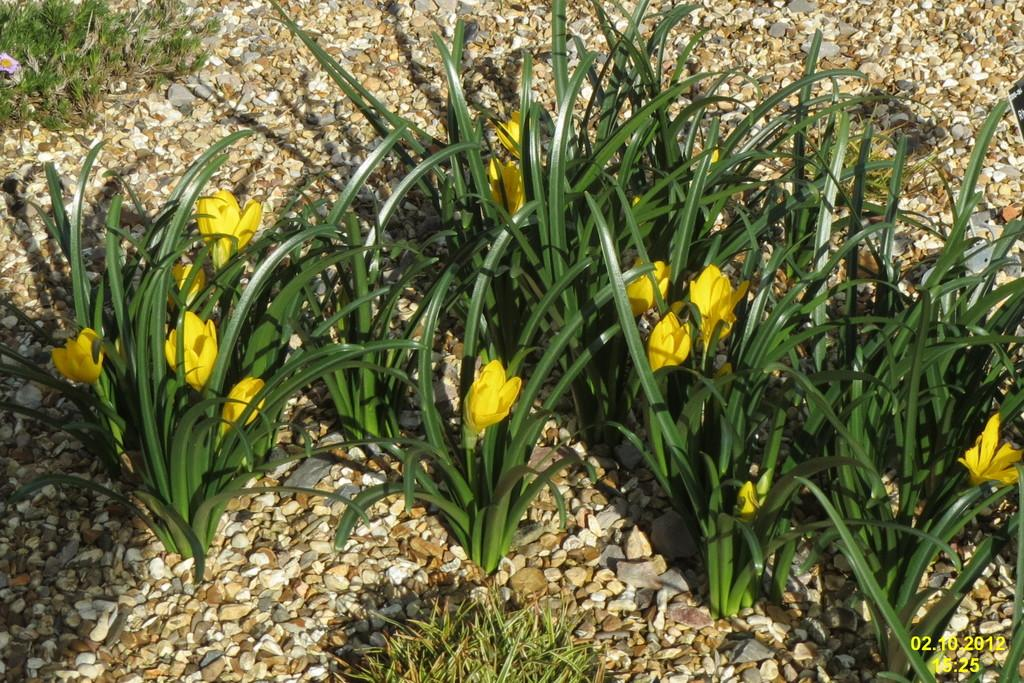What type of flowers can be seen in the image? There are yellow flowers in the image. What type of vegetation is present in the image besides the flowers? There is grass in the image. What type of ground surface is visible in the image? There are small pebble stones on the bottom side of the image. What title does the tramp have in the image? There is no tramp present in the image, so it is not possible to determine a title for one. 